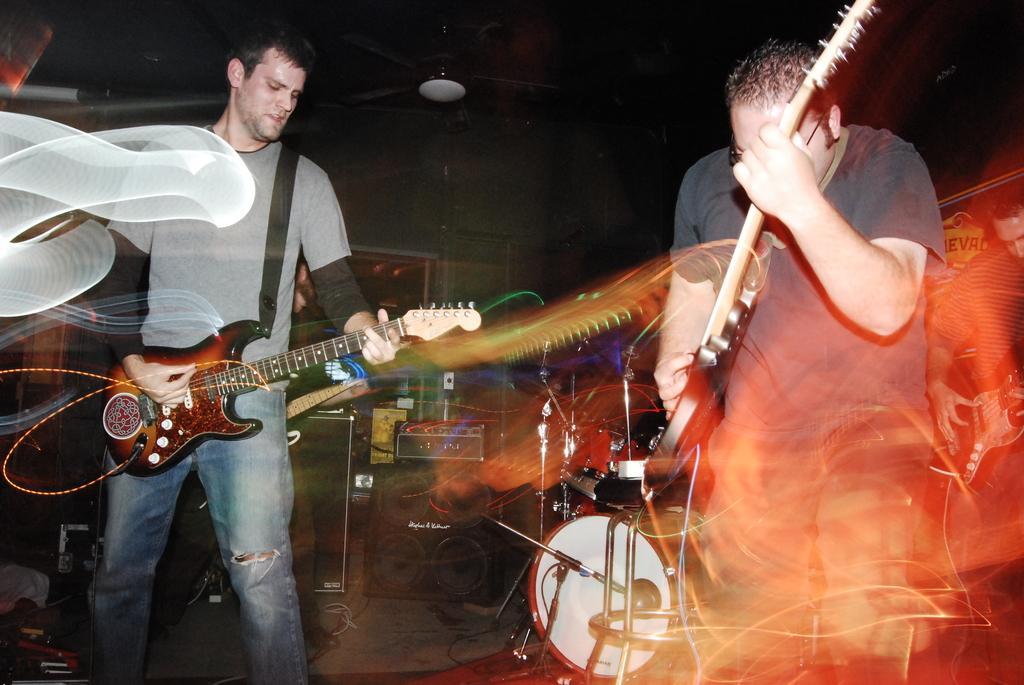Can you describe this image briefly? Here we can see two persons are playing guitar. This is floor and there are some musical instruments. On the background there is a wall and this is fan. 